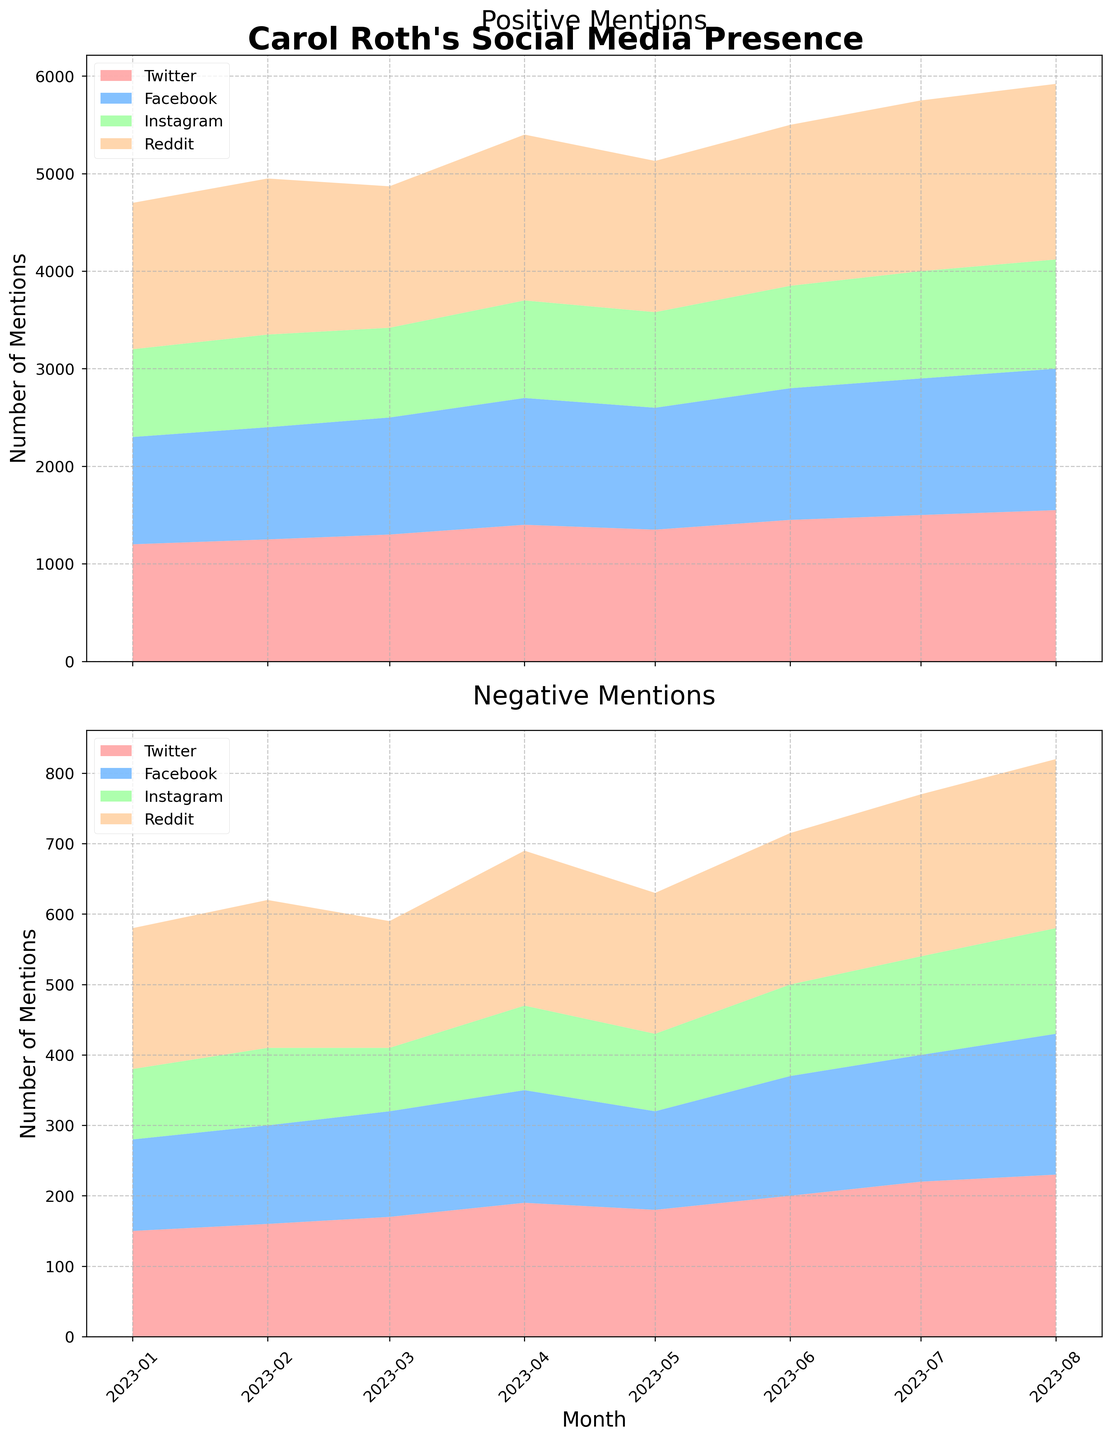What's the title of the figure? The title is displayed at the top center of the figure. It describes the overall theme of the figure, which is "Carol Roth's Social Media Presence."
Answer: Carol Roth's Social Media Presence How many different social media platforms are represented in the figure? To count the platforms, look at the legend in either of the two subplots. There are four listed platforms.
Answer: Four Which month had the highest number of positive mentions on Twitter? Look at the positive mentions subplot for the Twitter series (usually the first color in the legend). The peak occurs in August 2023.
Answer: August 2023 What is the range of months covered in the figure? The x-axis shows the range of dates, spanning from the first to the last tick. The figure covers from January 2023 to August 2023.
Answer: January 2023 to August 2023 Which platform had the lowest number of positive mentions in January 2023? By examining the first month in the positive mentions subplot, you can see that Reddit has the lowest number of positive mentions.
Answer: Reddit What is the trend of negative mentions on Instagram from January 2023 to August 2023? Observe the Instagram line in the negative mentions subplot from January 2023 to August 2023. The trend is increasing over time.
Answer: Increasing What is the difference between positive and negative mentions on Facebook in August 2023? Locate August 2023 for Facebook in both subplots. Positive mentions: 1550, negative mentions: 230. Difference: 1550 - 230 = 1320.
Answer: 1320 In which month did Reddit see a peak in positive mentions? Look at the positive mentions subplot for Reddit and identify the month with the highest area under the curve. The peak occurs in August 2023.
Answer: August 2023 How do the positive mentions on Instagram in April 2023 compare to those in May 2023? Compare the values of positive mentions for Instagram between April and May 2023. April has 1300, and May has 1250. April has more positive mentions than May.
Answer: April has more During which month did Carol Roth have the highest combined positive mentions across all platforms? Sum the positive mentions across all platforms for each month and compare. August 2023 has the highest combined positive mentions.
Answer: August 2023 